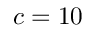Convert formula to latex. <formula><loc_0><loc_0><loc_500><loc_500>c = 1 0</formula> 